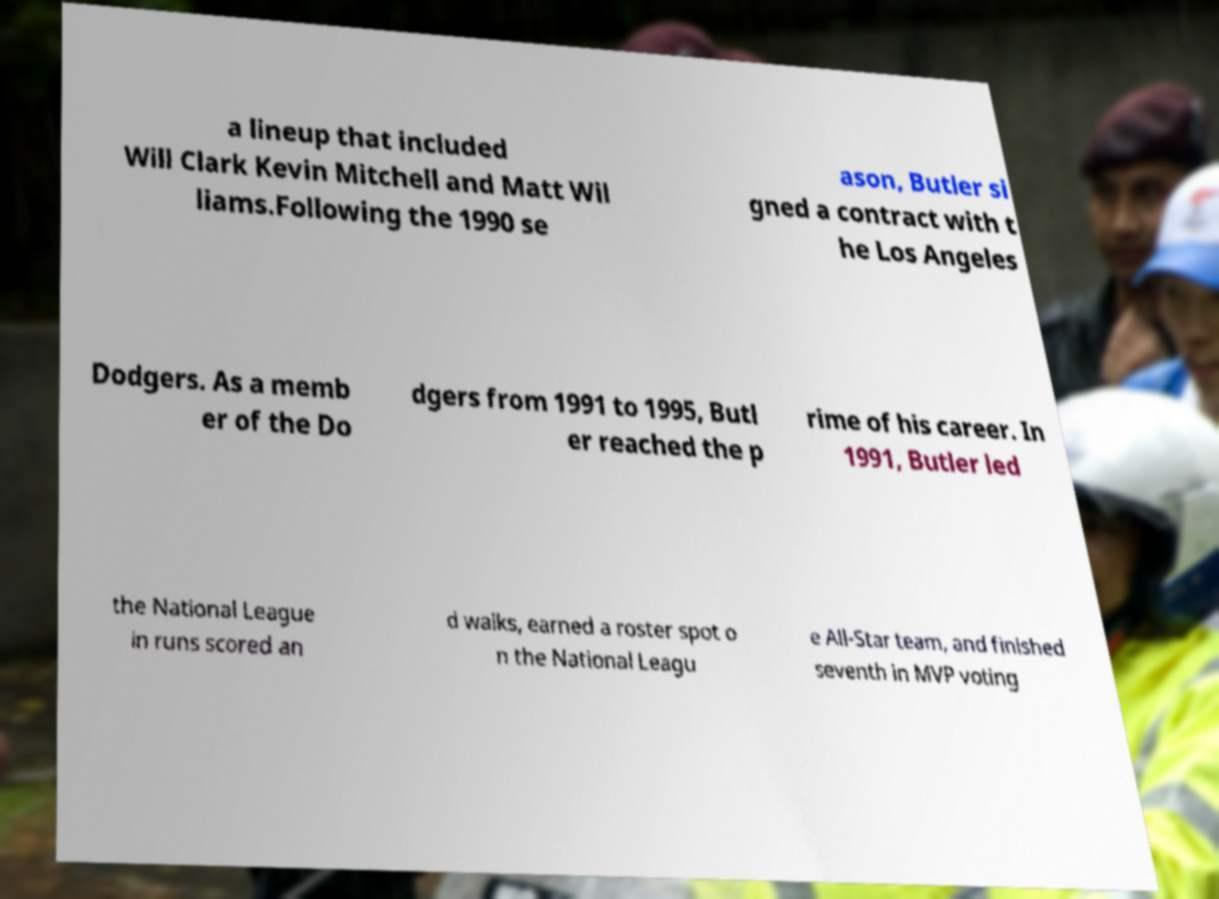For documentation purposes, I need the text within this image transcribed. Could you provide that? a lineup that included Will Clark Kevin Mitchell and Matt Wil liams.Following the 1990 se ason, Butler si gned a contract with t he Los Angeles Dodgers. As a memb er of the Do dgers from 1991 to 1995, Butl er reached the p rime of his career. In 1991, Butler led the National League in runs scored an d walks, earned a roster spot o n the National Leagu e All-Star team, and finished seventh in MVP voting 